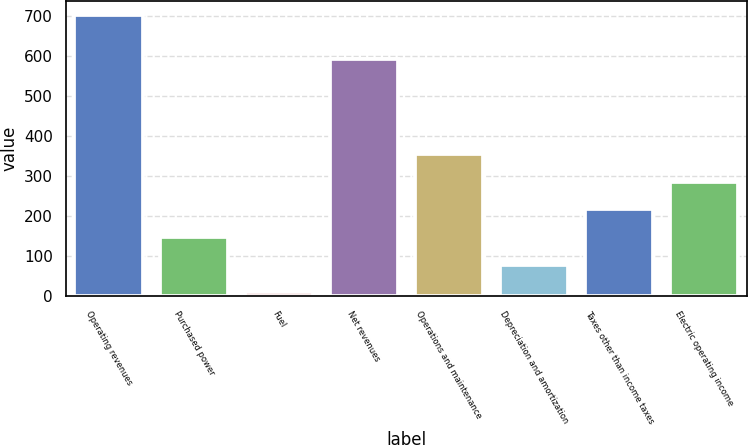<chart> <loc_0><loc_0><loc_500><loc_500><bar_chart><fcel>Operating revenues<fcel>Purchased power<fcel>Fuel<fcel>Net revenues<fcel>Operations and maintenance<fcel>Depreciation and amortization<fcel>Taxes other than income taxes<fcel>Electric operating income<nl><fcel>702<fcel>147.6<fcel>9<fcel>593<fcel>355.5<fcel>78.3<fcel>216.9<fcel>286.2<nl></chart> 